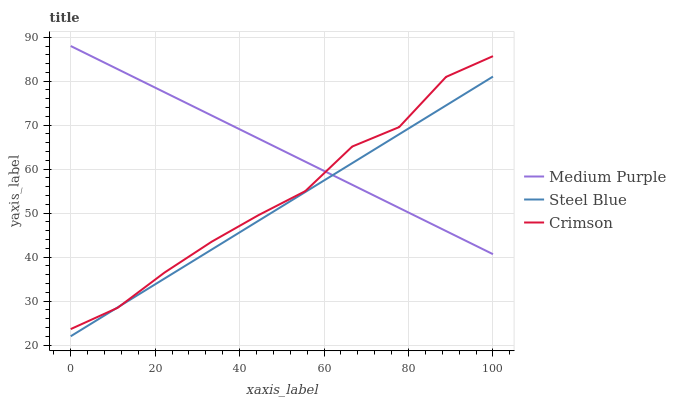Does Steel Blue have the minimum area under the curve?
Answer yes or no. Yes. Does Medium Purple have the maximum area under the curve?
Answer yes or no. Yes. Does Crimson have the minimum area under the curve?
Answer yes or no. No. Does Crimson have the maximum area under the curve?
Answer yes or no. No. Is Steel Blue the smoothest?
Answer yes or no. Yes. Is Crimson the roughest?
Answer yes or no. Yes. Is Crimson the smoothest?
Answer yes or no. No. Is Steel Blue the roughest?
Answer yes or no. No. Does Steel Blue have the lowest value?
Answer yes or no. Yes. Does Crimson have the lowest value?
Answer yes or no. No. Does Medium Purple have the highest value?
Answer yes or no. Yes. Does Crimson have the highest value?
Answer yes or no. No. Does Crimson intersect Steel Blue?
Answer yes or no. Yes. Is Crimson less than Steel Blue?
Answer yes or no. No. Is Crimson greater than Steel Blue?
Answer yes or no. No. 